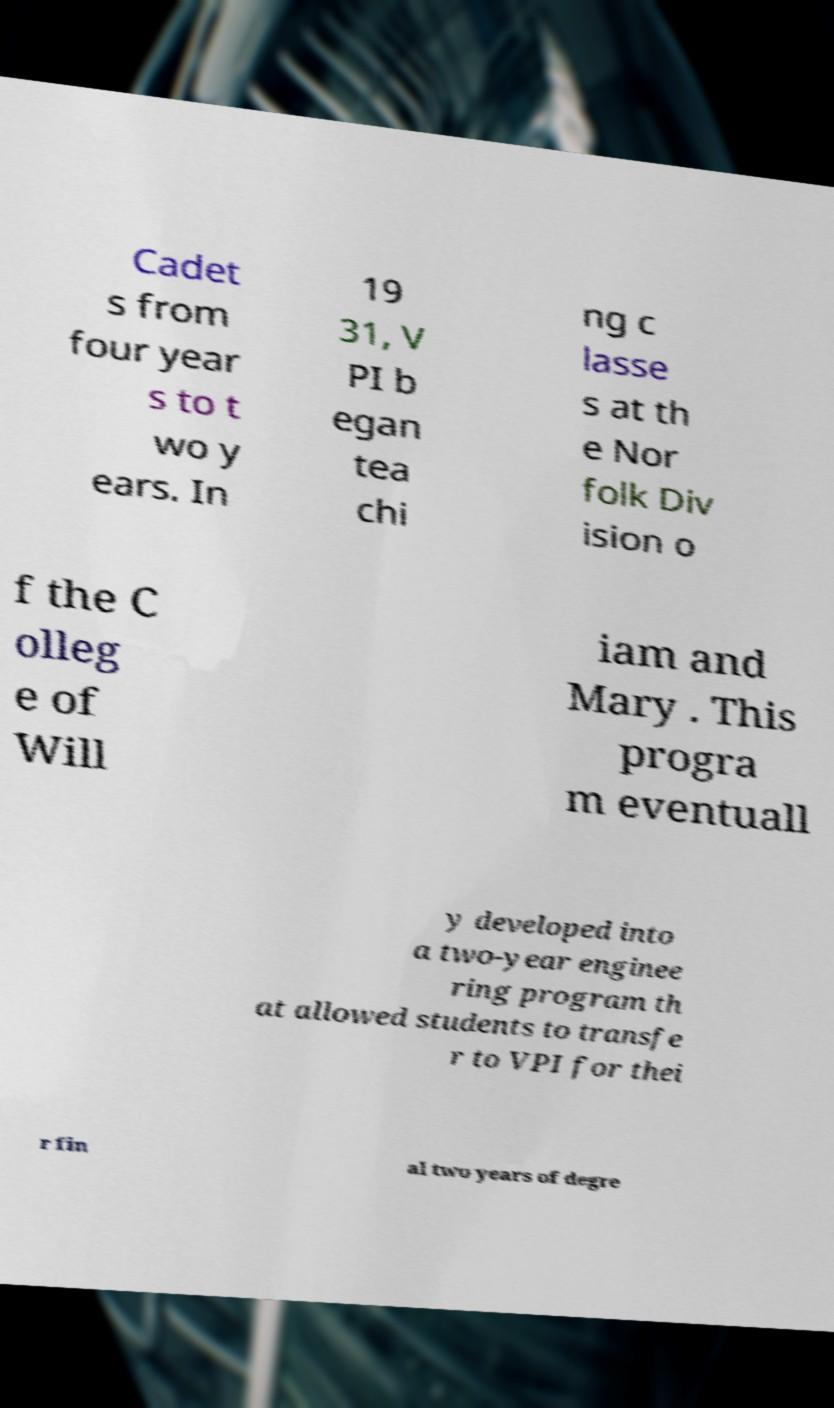Can you read and provide the text displayed in the image?This photo seems to have some interesting text. Can you extract and type it out for me? Cadet s from four year s to t wo y ears. In 19 31, V PI b egan tea chi ng c lasse s at th e Nor folk Div ision o f the C olleg e of Will iam and Mary . This progra m eventuall y developed into a two-year enginee ring program th at allowed students to transfe r to VPI for thei r fin al two years of degre 